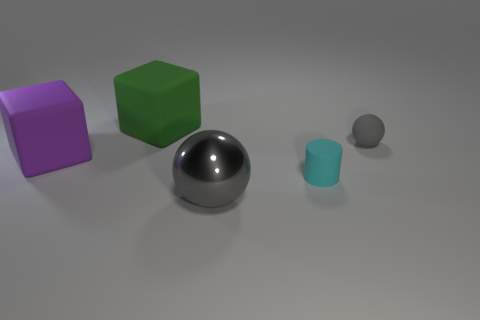Are there more big blocks that are behind the big shiny ball than tiny gray matte balls? Indeed, there are more large blocks positioned behind the big shiny ball when compared to the number of tiny gray matte balls present in the scene. 